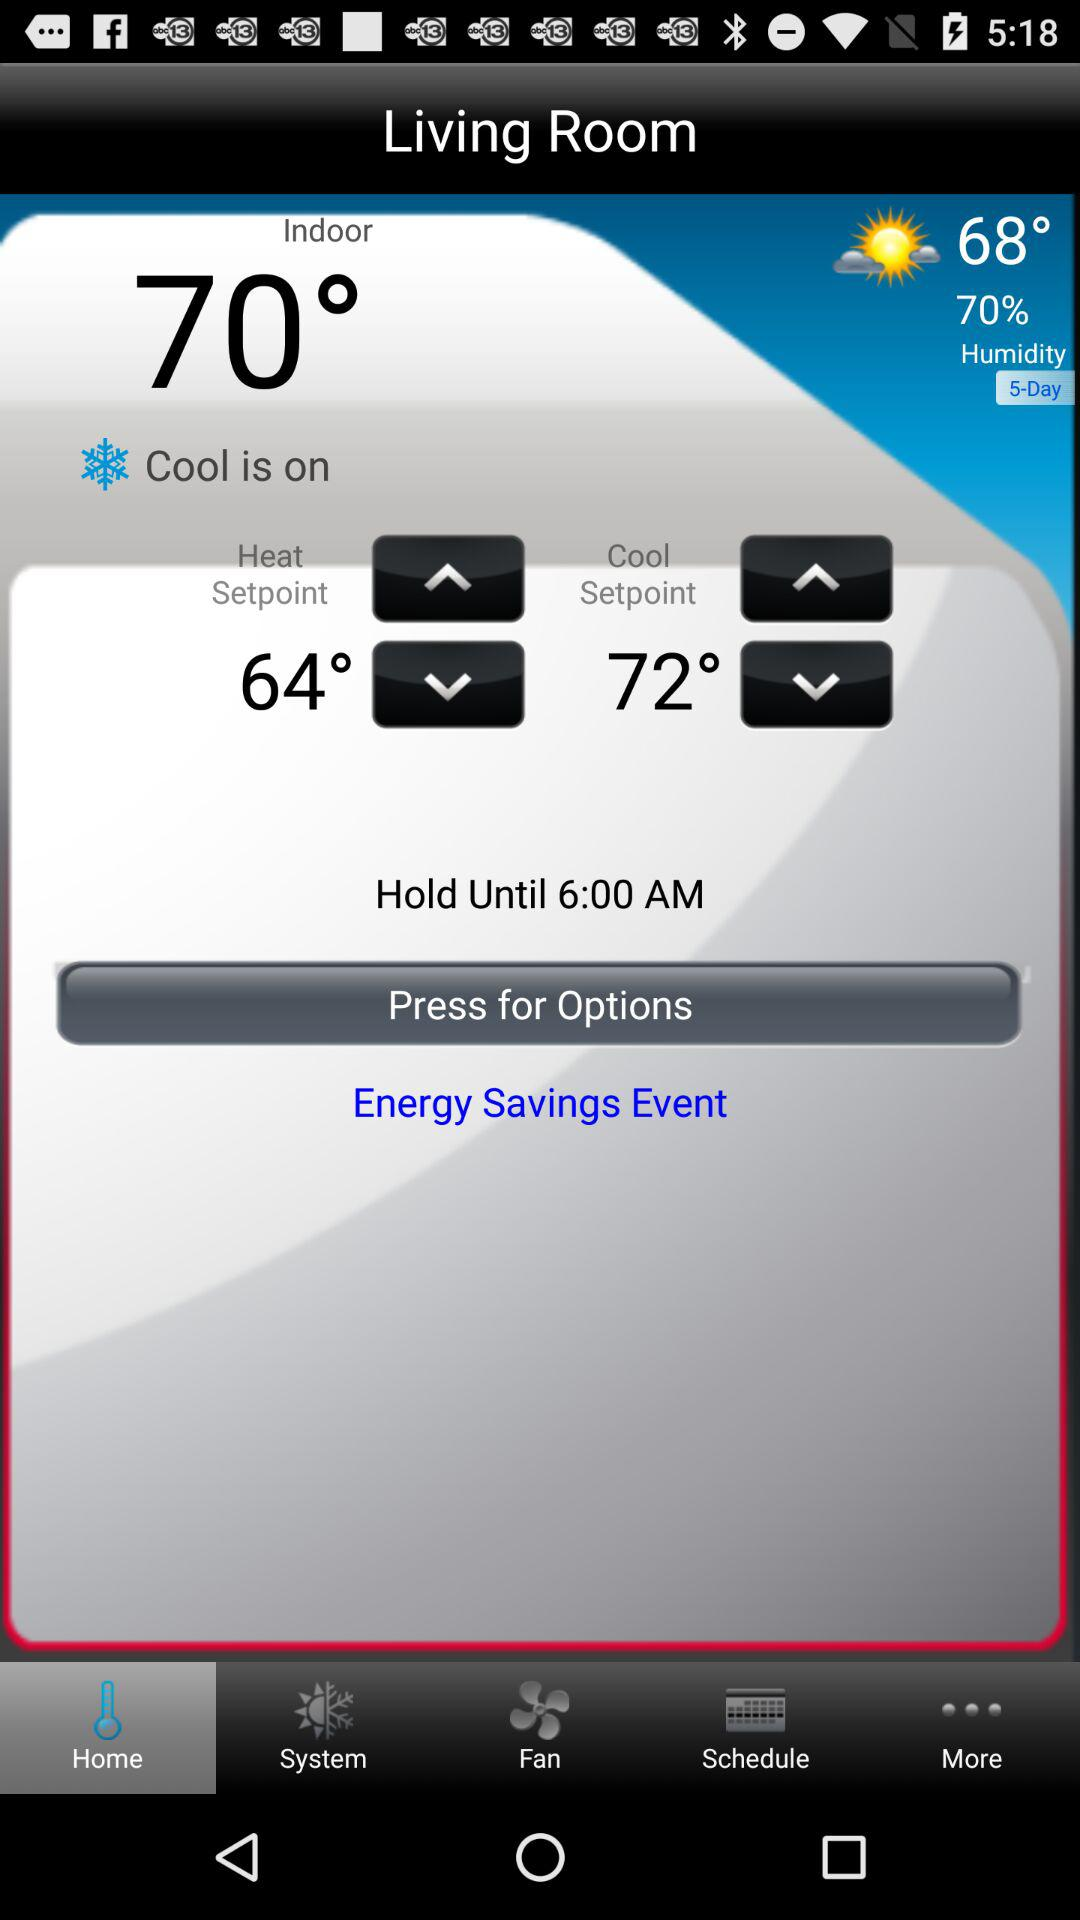What is the current humidity level?
Answer the question using a single word or phrase. 70% 